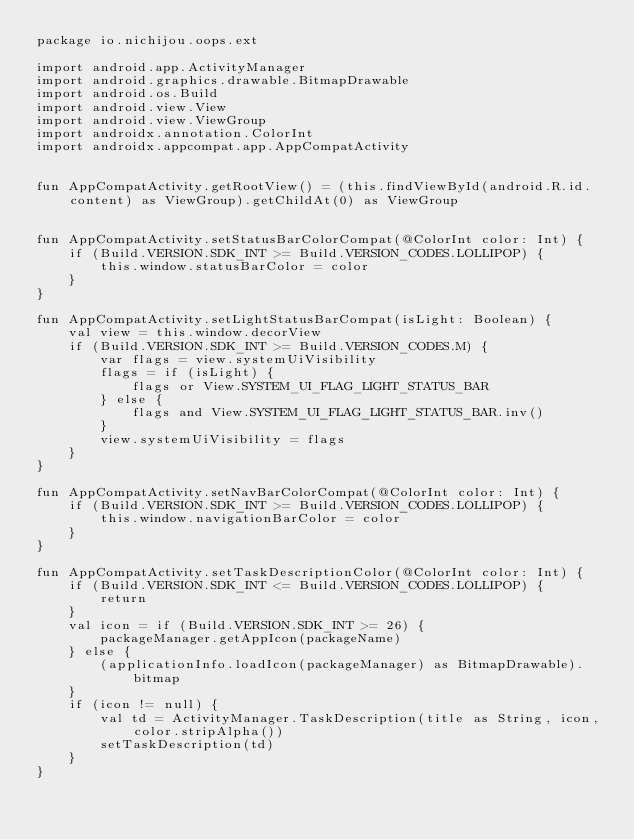Convert code to text. <code><loc_0><loc_0><loc_500><loc_500><_Kotlin_>package io.nichijou.oops.ext

import android.app.ActivityManager
import android.graphics.drawable.BitmapDrawable
import android.os.Build
import android.view.View
import android.view.ViewGroup
import androidx.annotation.ColorInt
import androidx.appcompat.app.AppCompatActivity


fun AppCompatActivity.getRootView() = (this.findViewById(android.R.id.content) as ViewGroup).getChildAt(0) as ViewGroup


fun AppCompatActivity.setStatusBarColorCompat(@ColorInt color: Int) {
    if (Build.VERSION.SDK_INT >= Build.VERSION_CODES.LOLLIPOP) {
        this.window.statusBarColor = color
    }
}

fun AppCompatActivity.setLightStatusBarCompat(isLight: Boolean) {
    val view = this.window.decorView
    if (Build.VERSION.SDK_INT >= Build.VERSION_CODES.M) {
        var flags = view.systemUiVisibility
        flags = if (isLight) {
            flags or View.SYSTEM_UI_FLAG_LIGHT_STATUS_BAR
        } else {
            flags and View.SYSTEM_UI_FLAG_LIGHT_STATUS_BAR.inv()
        }
        view.systemUiVisibility = flags
    }
}

fun AppCompatActivity.setNavBarColorCompat(@ColorInt color: Int) {
    if (Build.VERSION.SDK_INT >= Build.VERSION_CODES.LOLLIPOP) {
        this.window.navigationBarColor = color
    }
}

fun AppCompatActivity.setTaskDescriptionColor(@ColorInt color: Int) {
    if (Build.VERSION.SDK_INT <= Build.VERSION_CODES.LOLLIPOP) {
        return
    }
    val icon = if (Build.VERSION.SDK_INT >= 26) {
        packageManager.getAppIcon(packageName)
    } else {
        (applicationInfo.loadIcon(packageManager) as BitmapDrawable).bitmap
    }
    if (icon != null) {
        val td = ActivityManager.TaskDescription(title as String, icon, color.stripAlpha())
        setTaskDescription(td)
    }
}
</code> 